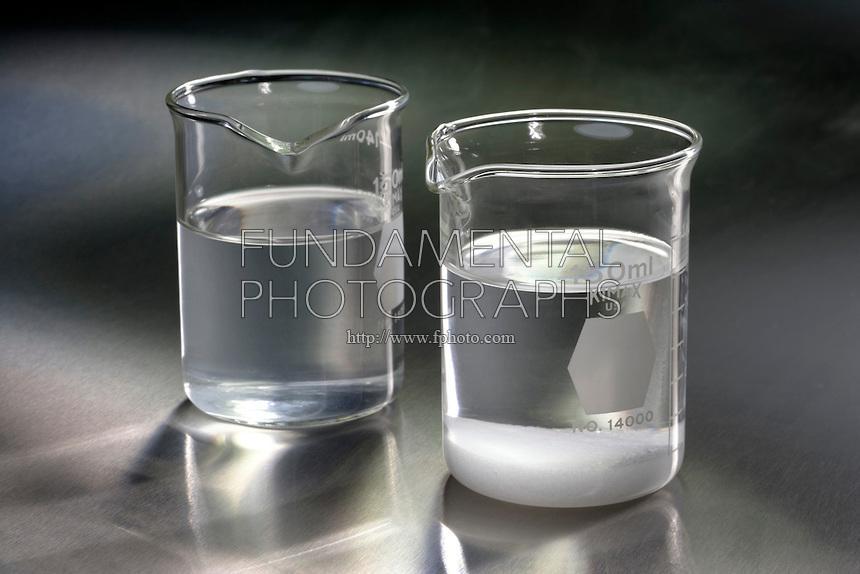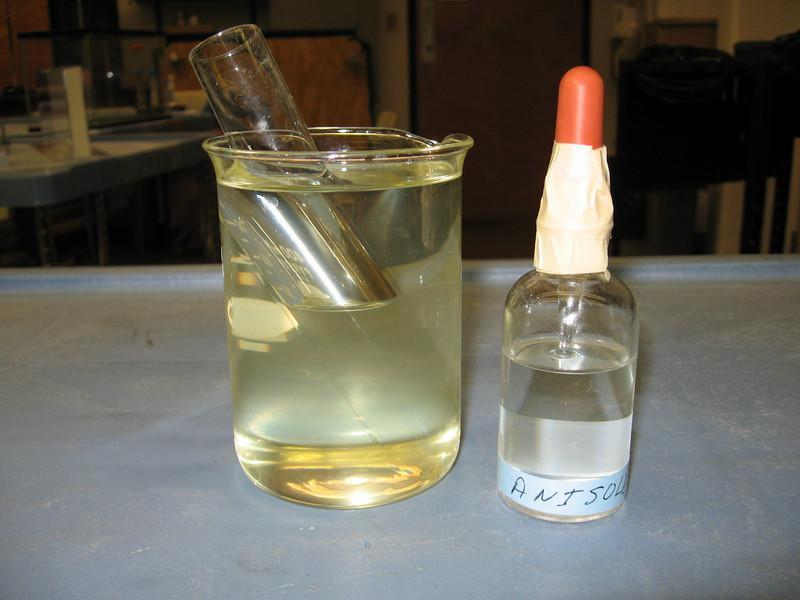The first image is the image on the left, the second image is the image on the right. Evaluate the accuracy of this statement regarding the images: "There are four beakers in total.". Is it true? Answer yes or no. No. 